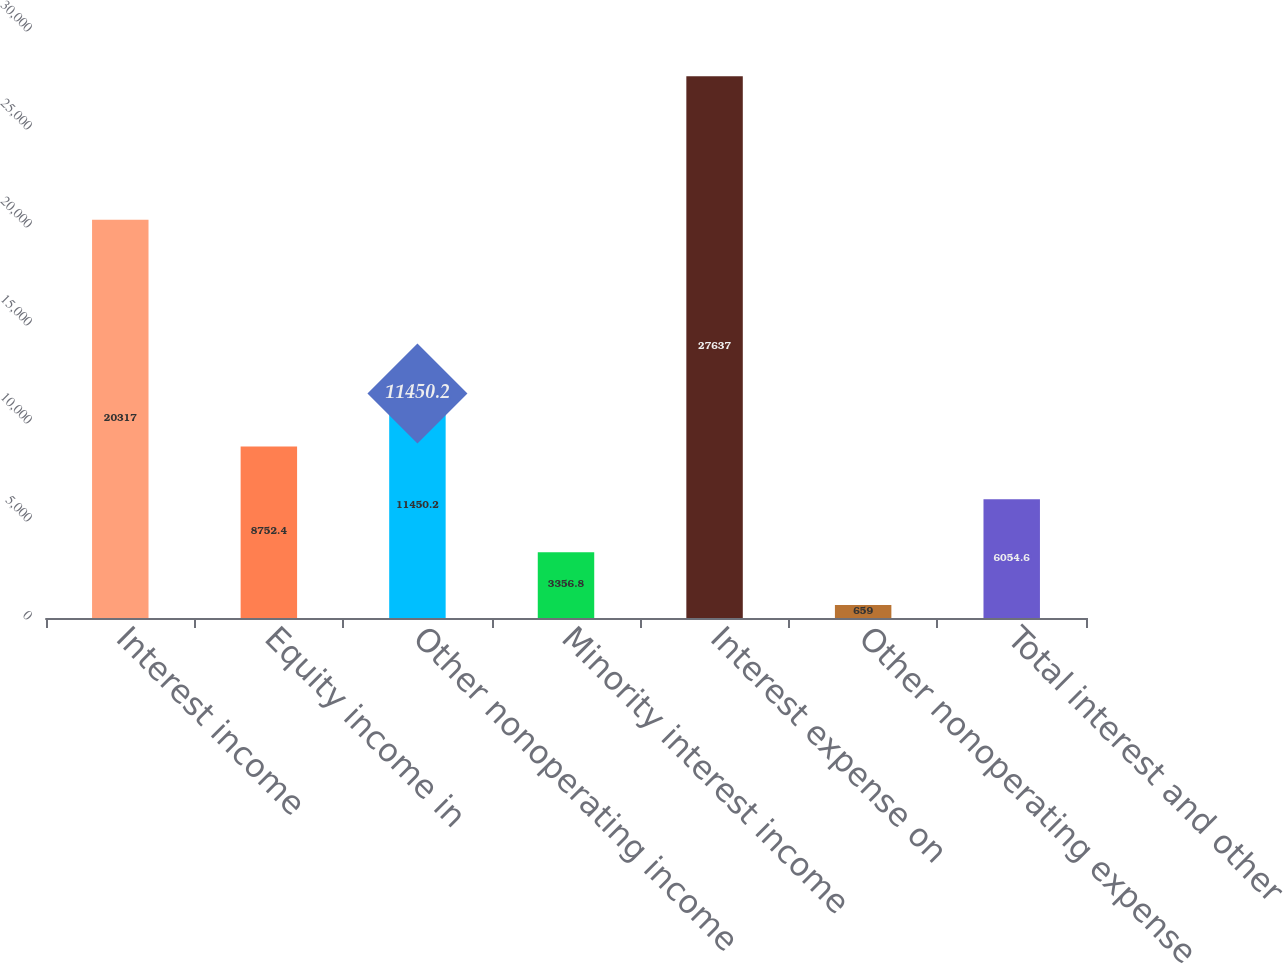<chart> <loc_0><loc_0><loc_500><loc_500><bar_chart><fcel>Interest income<fcel>Equity income in<fcel>Other nonoperating income<fcel>Minority interest income<fcel>Interest expense on<fcel>Other nonoperating expense<fcel>Total interest and other<nl><fcel>20317<fcel>8752.4<fcel>11450.2<fcel>3356.8<fcel>27637<fcel>659<fcel>6054.6<nl></chart> 